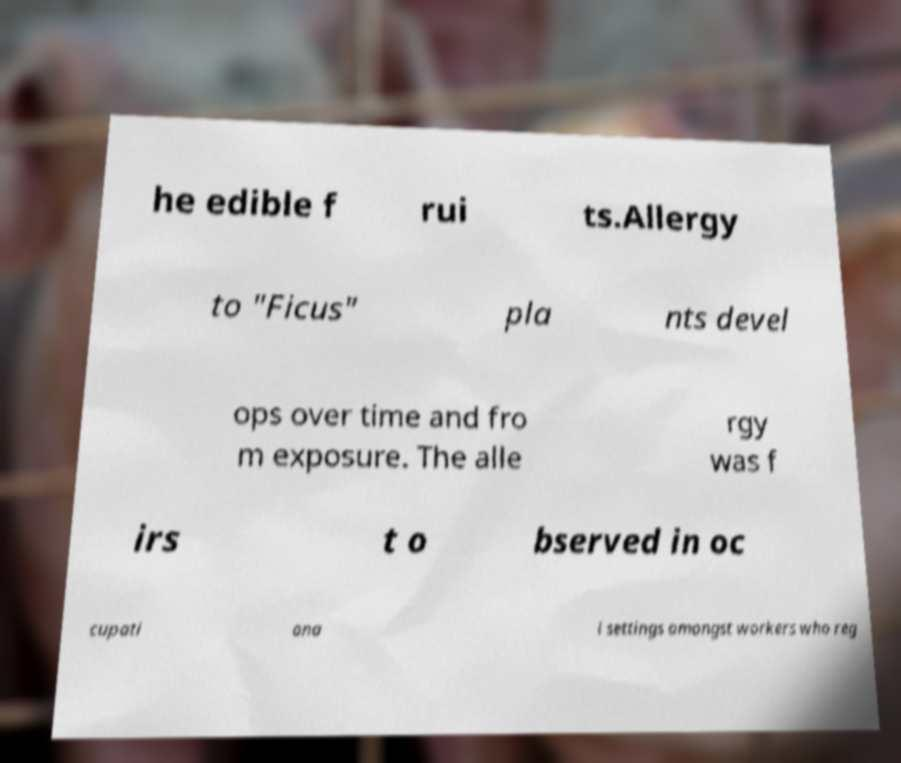Could you extract and type out the text from this image? he edible f rui ts.Allergy to "Ficus" pla nts devel ops over time and fro m exposure. The alle rgy was f irs t o bserved in oc cupati ona l settings amongst workers who reg 